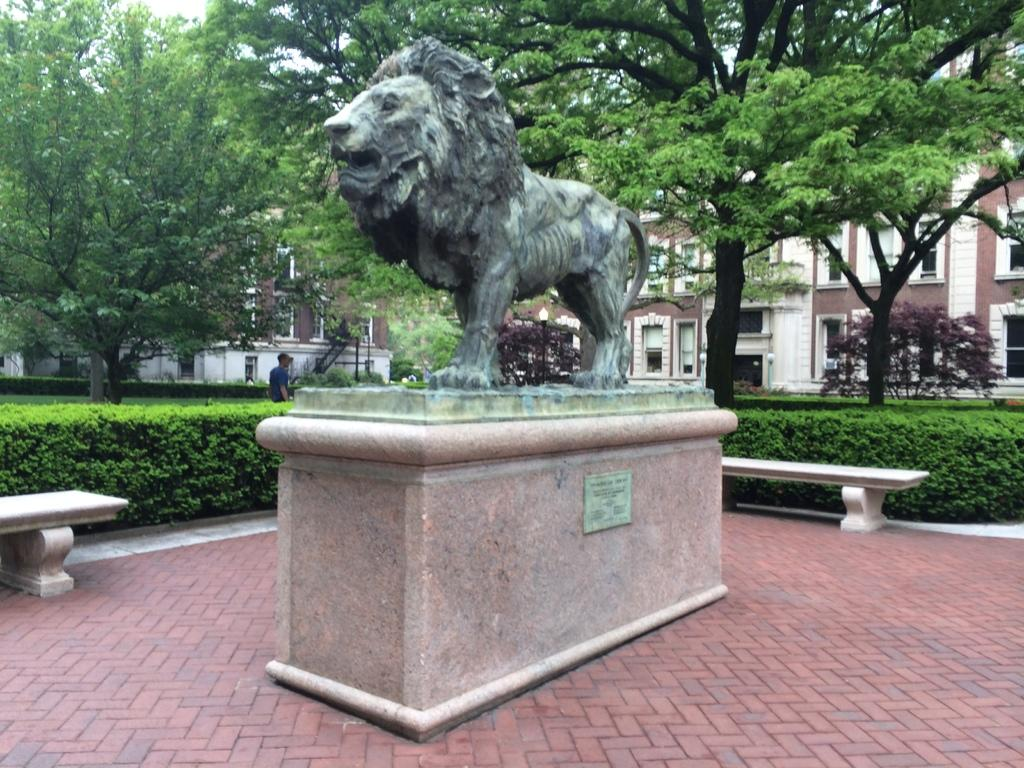What is the main subject in the center of the image? There is a statue in the center of the image. What can be used for sitting in the image? There are benches in the image. What type of natural elements can be seen in the background of the image? There are trees in the background of the image. What type of man-made structures can be seen in the background of the image? There are buildings in the background of the image. Can you describe the person in the background of the image? There is a person in the background of the image. What type of landscaping can be seen in the background of the image? There are hedges in the background of the image. What news is the statue reporting in the image? There is no news being reported in the image, as the statue is an inanimate object. 